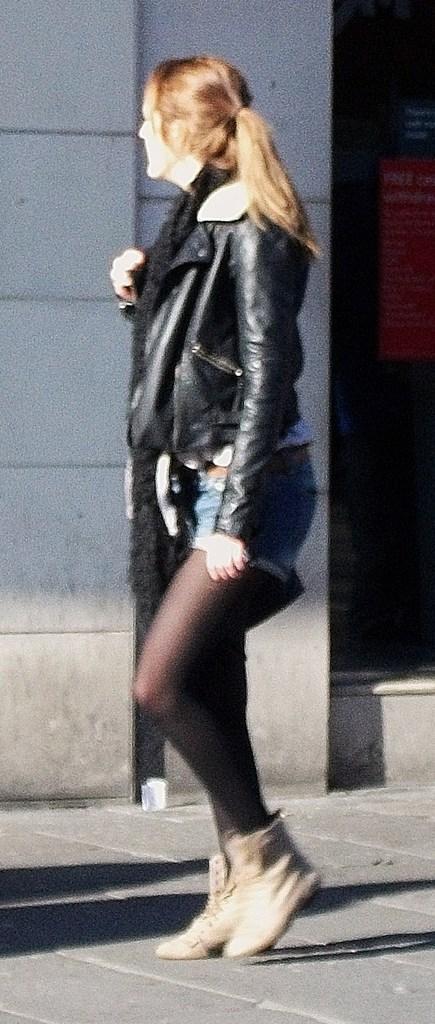Describe this image in one or two sentences. In this image we can see a woman wearing black jacket and boots is walking on the road. In the background, we can see the wall and posts here. 